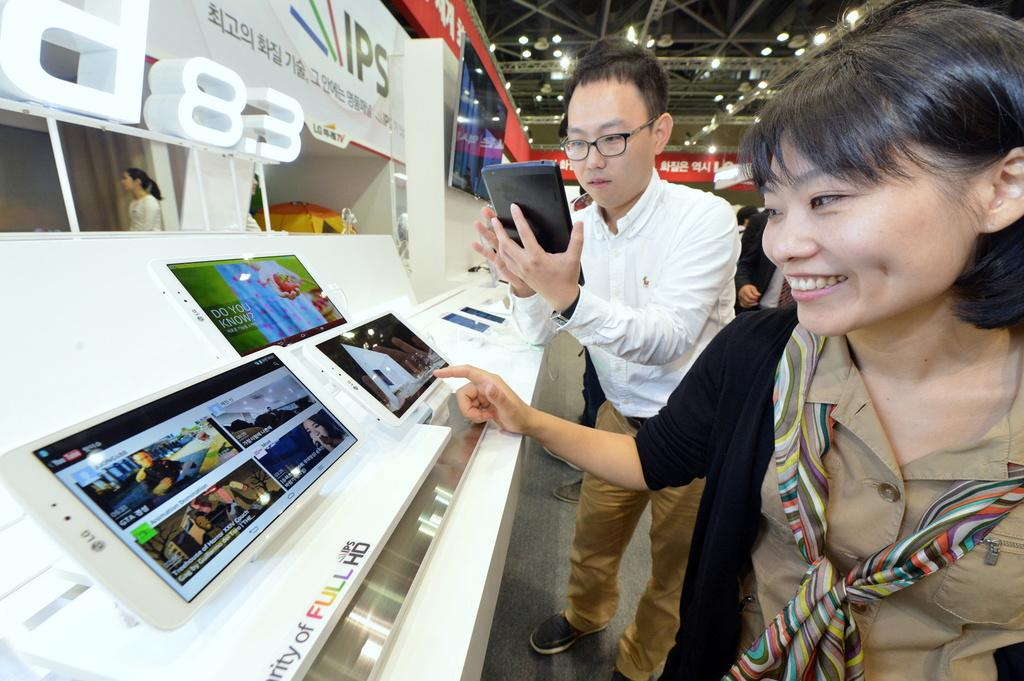What is the general activity of the people in the image? There are people standing in the image, which suggests they might be waiting or observing something. What object is the man holding in his hand? The man is holding a tablet in his hand. Can you describe the arrangement of the tablets in the image? There are tablets on a rack in the image. What type of lighting is present in the image? There are lightings on the top of the image. What is the opinion of the servant about the tank in the image? There is no servant or tank present in the image, so it is not possible to answer that question. 